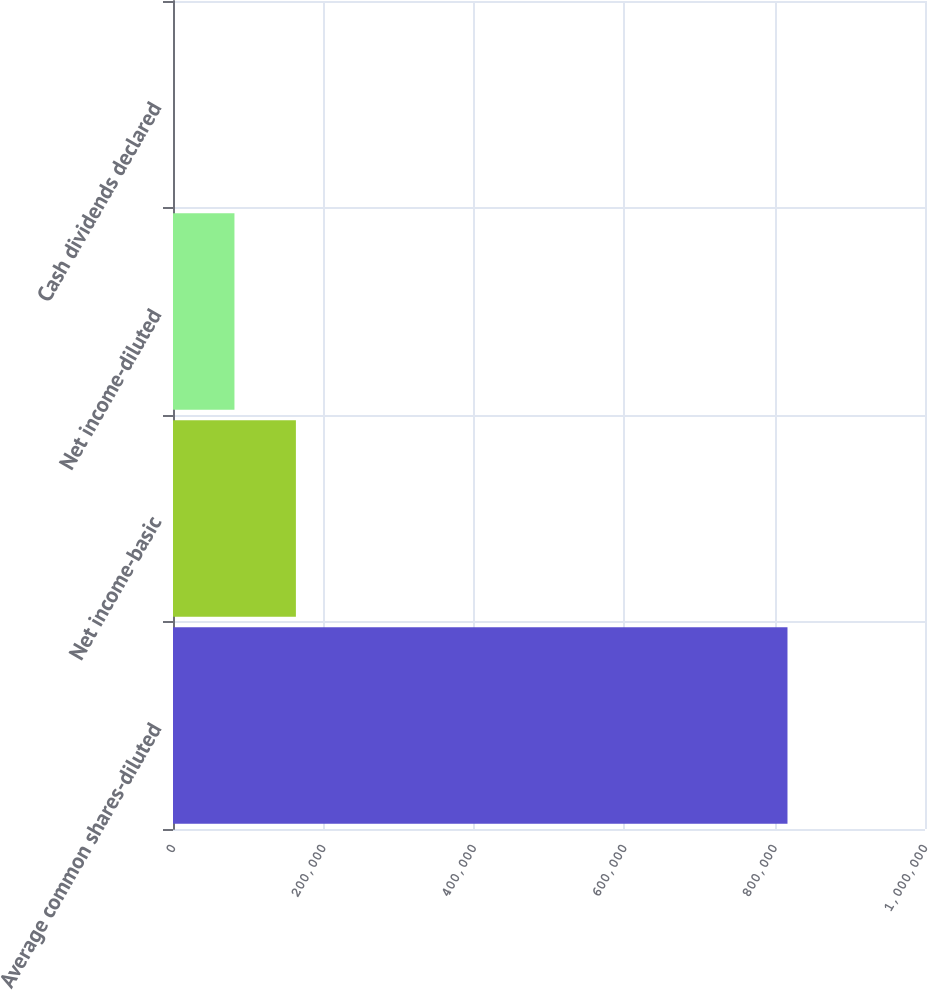Convert chart to OTSL. <chart><loc_0><loc_0><loc_500><loc_500><bar_chart><fcel>Average common shares-diluted<fcel>Net income-basic<fcel>Net income-diluted<fcel>Cash dividends declared<nl><fcel>817129<fcel>163426<fcel>81713.1<fcel>0.25<nl></chart> 